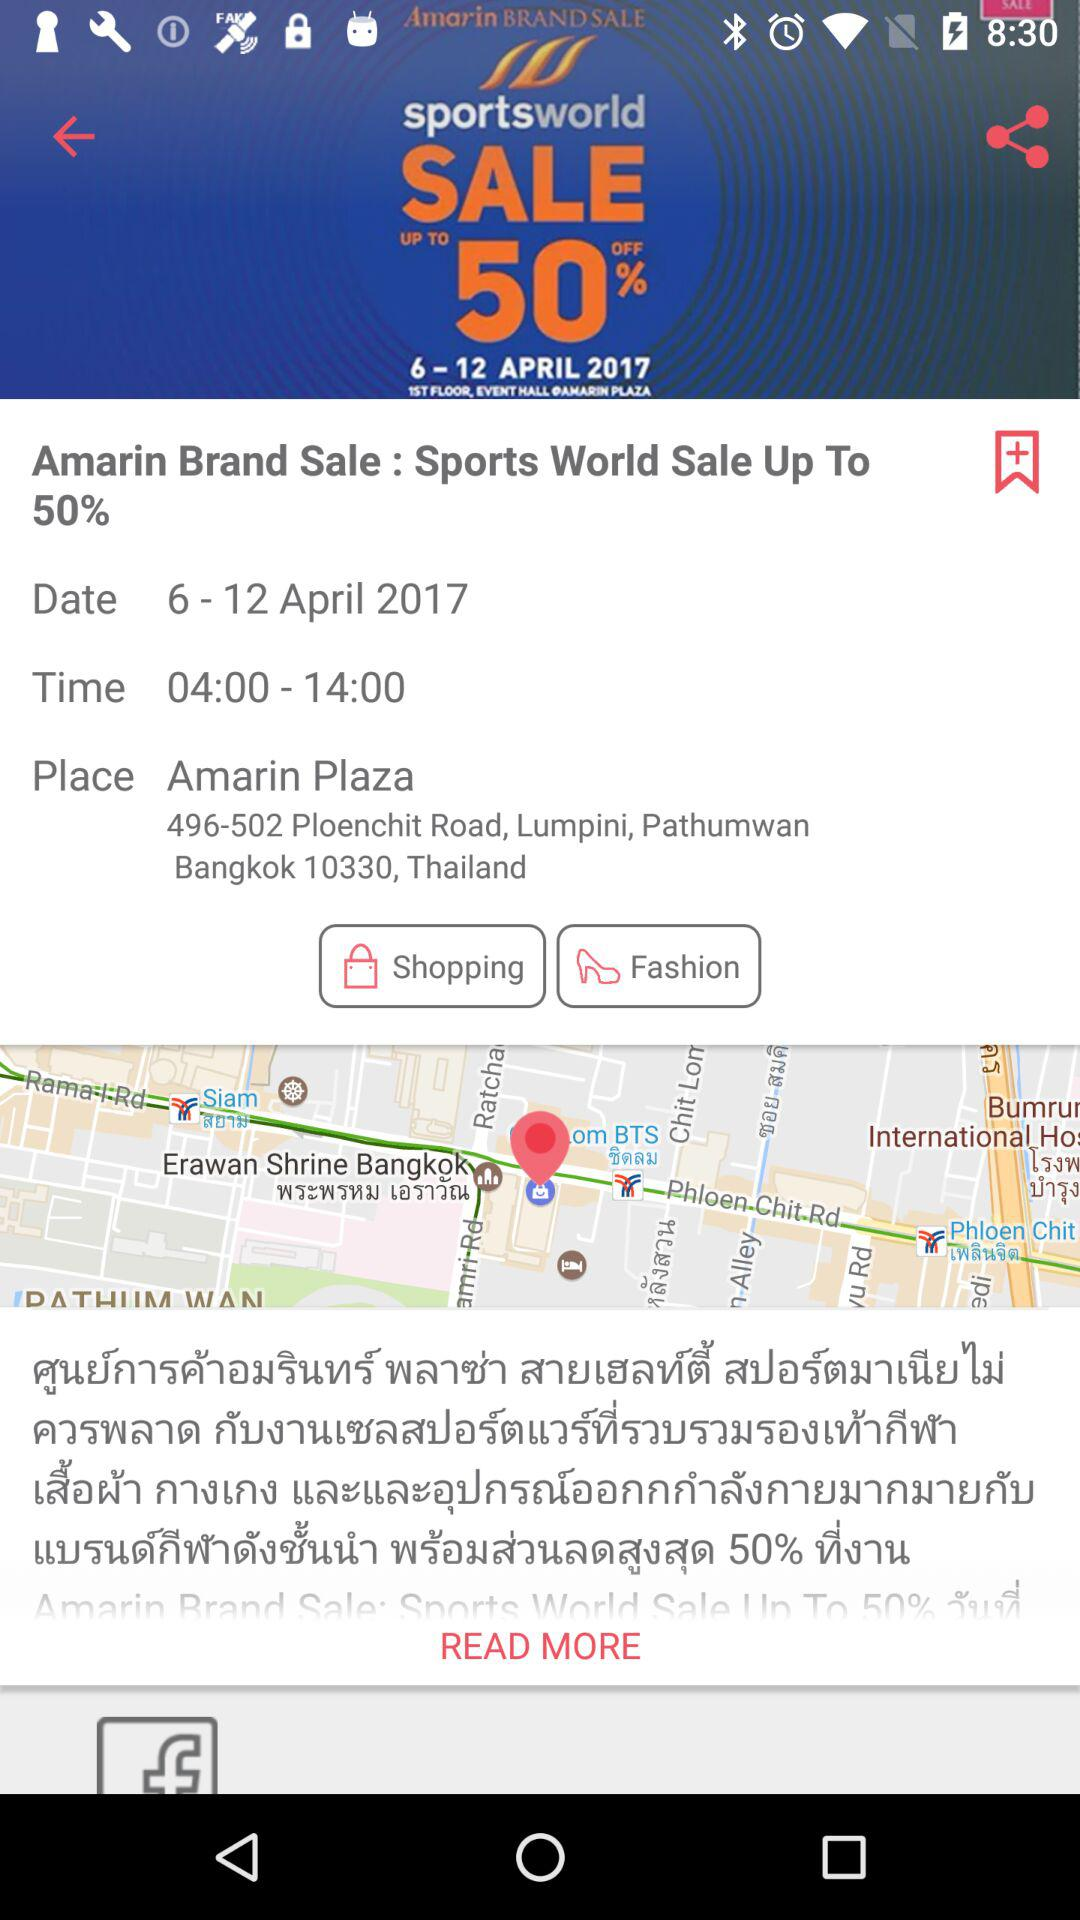What is the mentioned time? The mentioned time is 04:00 - 14:00. 